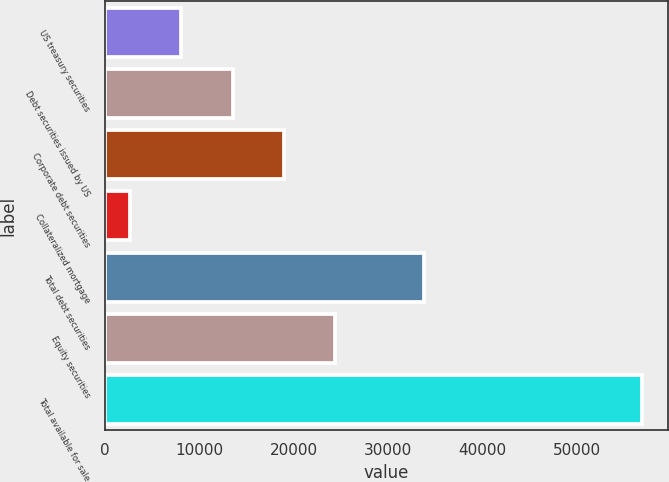<chart> <loc_0><loc_0><loc_500><loc_500><bar_chart><fcel>US treasury securities<fcel>Debt securities issued by US<fcel>Corporate debt securities<fcel>Collateralized mortgage<fcel>Total debt securities<fcel>Equity securities<fcel>Total available for sale<nl><fcel>8128<fcel>13536<fcel>18944<fcel>2720<fcel>33773<fcel>24352<fcel>56800<nl></chart> 